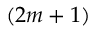Convert formula to latex. <formula><loc_0><loc_0><loc_500><loc_500>( 2 m + 1 )</formula> 